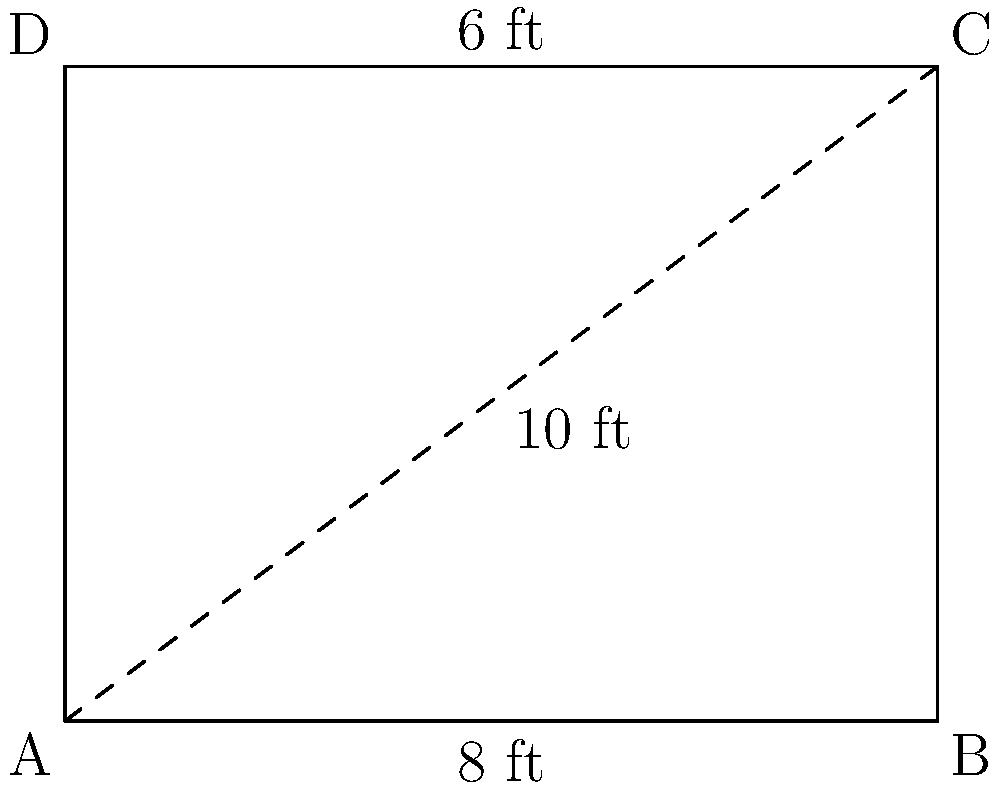In your ancestor's diary, you find a sketch of a rectangular room with only the diagonal measurement recorded as 10 feet. If the width of the room is 6 feet, what is the length of the room? To solve this problem, we can use the Pythagorean theorem, which states that in a right triangle, the square of the hypotenuse (diagonal) is equal to the sum of squares of the other two sides.

Let's approach this step-by-step:

1) Let the length of the room be $x$ feet.
2) We know the width is 6 feet and the diagonal is 10 feet.
3) Using the Pythagorean theorem:

   $x^2 + 6^2 = 10^2$

4) Simplify:
   $x^2 + 36 = 100$

5) Subtract 36 from both sides:
   $x^2 = 64$

6) Take the square root of both sides:
   $x = \sqrt{64} = 8$

Therefore, the length of the room is 8 feet.
Answer: 8 feet 